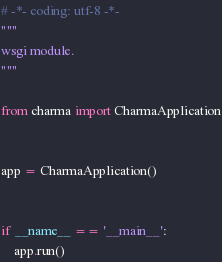Convert code to text. <code><loc_0><loc_0><loc_500><loc_500><_Python_># -*- coding: utf-8 -*-
"""
wsgi module.
"""

from charma import CharmaApplication


app = CharmaApplication()


if __name__ == '__main__':
    app.run()
</code> 